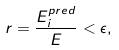Convert formula to latex. <formula><loc_0><loc_0><loc_500><loc_500>r = \frac { E _ { i } ^ { p r e d } } { E } < \epsilon ,</formula> 